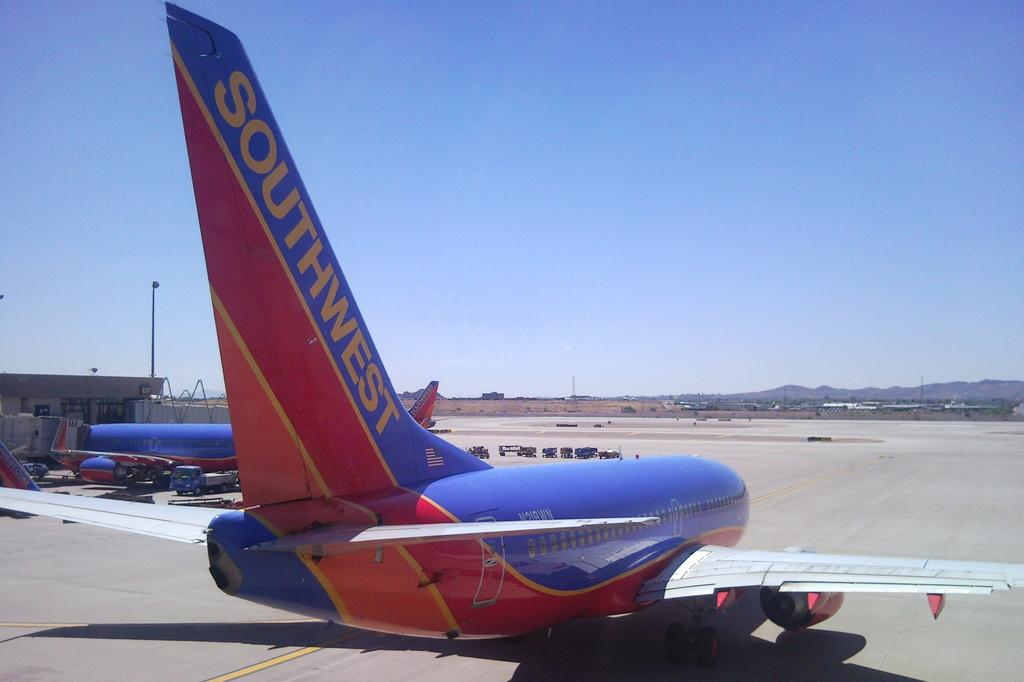<image>
Render a clear and concise summary of the photo. the tail end of a SouthWest plane taxiing on a runaway 